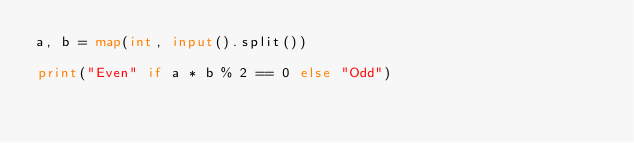<code> <loc_0><loc_0><loc_500><loc_500><_Python_>a, b = map(int, input().split())

print("Even" if a * b % 2 == 0 else "Odd")</code> 